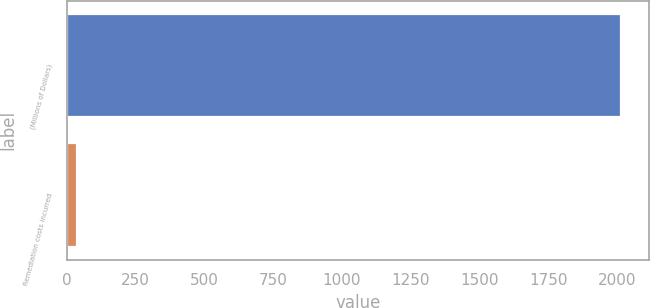Convert chart. <chart><loc_0><loc_0><loc_500><loc_500><bar_chart><fcel>(Millions of Dollars)<fcel>Remediation costs incurred<nl><fcel>2015<fcel>37<nl></chart> 